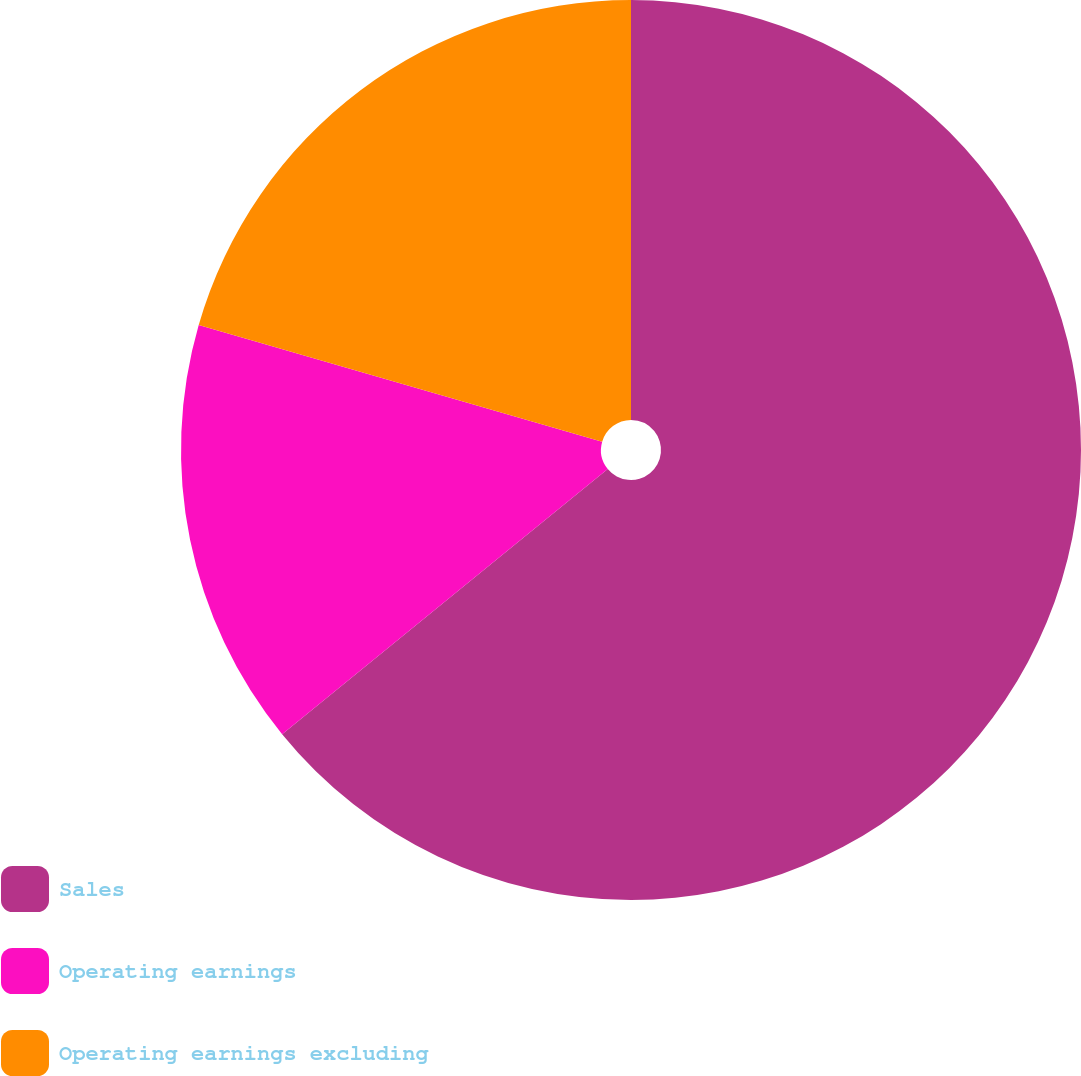Convert chart. <chart><loc_0><loc_0><loc_500><loc_500><pie_chart><fcel>Sales<fcel>Operating earnings<fcel>Operating earnings excluding<nl><fcel>64.12%<fcel>15.36%<fcel>20.52%<nl></chart> 